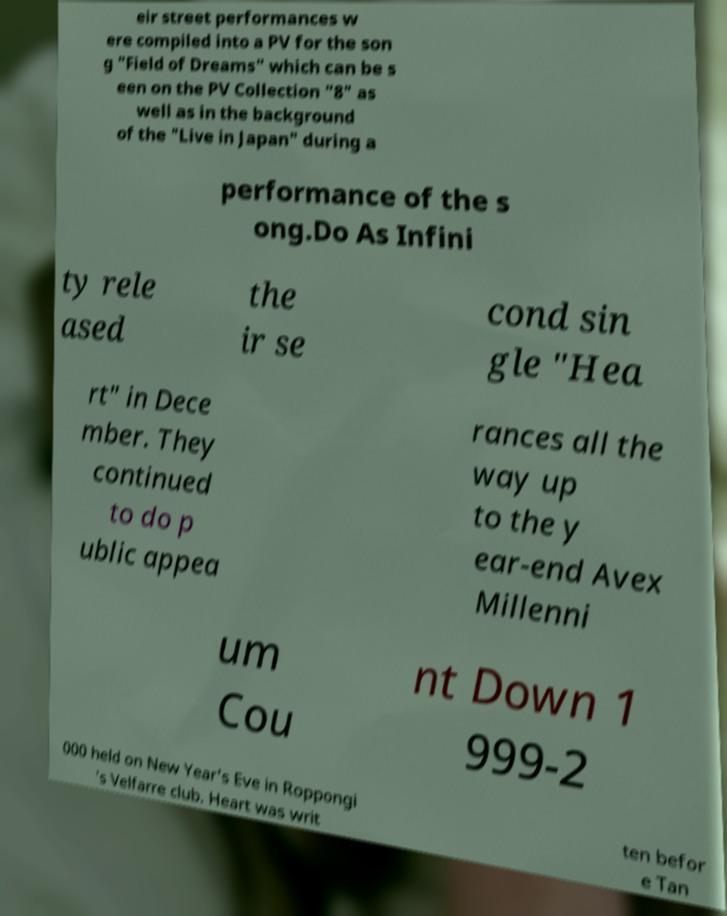Please read and relay the text visible in this image. What does it say? eir street performances w ere compiled into a PV for the son g "Field of Dreams" which can be s een on the PV Collection "8" as well as in the background of the "Live in Japan" during a performance of the s ong.Do As Infini ty rele ased the ir se cond sin gle "Hea rt" in Dece mber. They continued to do p ublic appea rances all the way up to the y ear-end Avex Millenni um Cou nt Down 1 999-2 000 held on New Year's Eve in Roppongi 's Velfarre club. Heart was writ ten befor e Tan 